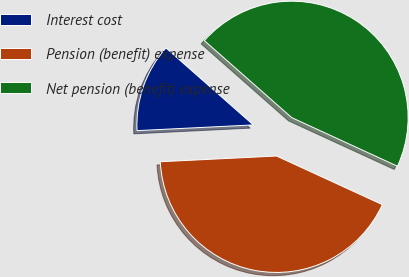<chart> <loc_0><loc_0><loc_500><loc_500><pie_chart><fcel>Interest cost<fcel>Pension (benefit) expense<fcel>Net pension (benefit) expense<nl><fcel>12.28%<fcel>42.36%<fcel>45.36%<nl></chart> 